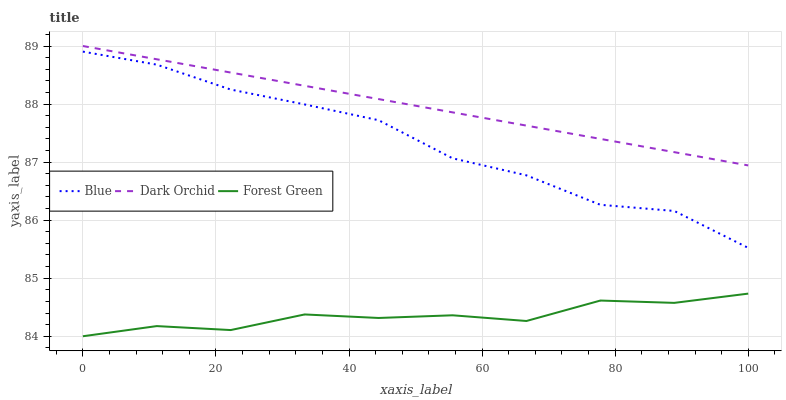Does Forest Green have the minimum area under the curve?
Answer yes or no. Yes. Does Dark Orchid have the maximum area under the curve?
Answer yes or no. Yes. Does Dark Orchid have the minimum area under the curve?
Answer yes or no. No. Does Forest Green have the maximum area under the curve?
Answer yes or no. No. Is Dark Orchid the smoothest?
Answer yes or no. Yes. Is Blue the roughest?
Answer yes or no. Yes. Is Forest Green the smoothest?
Answer yes or no. No. Is Forest Green the roughest?
Answer yes or no. No. Does Dark Orchid have the lowest value?
Answer yes or no. No. Does Dark Orchid have the highest value?
Answer yes or no. Yes. Does Forest Green have the highest value?
Answer yes or no. No. Is Forest Green less than Blue?
Answer yes or no. Yes. Is Dark Orchid greater than Blue?
Answer yes or no. Yes. Does Forest Green intersect Blue?
Answer yes or no. No. 